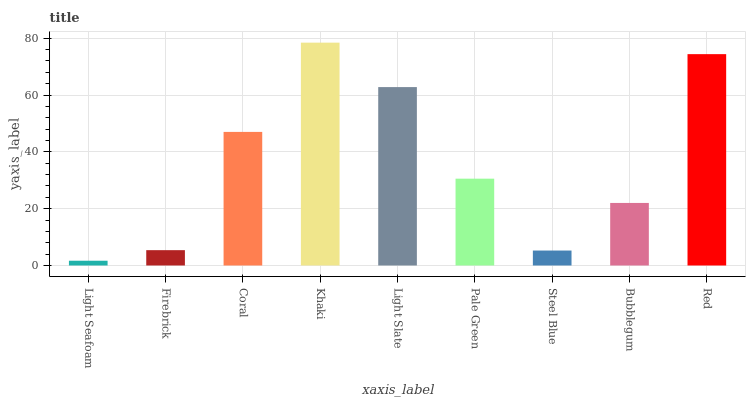Is Light Seafoam the minimum?
Answer yes or no. Yes. Is Khaki the maximum?
Answer yes or no. Yes. Is Firebrick the minimum?
Answer yes or no. No. Is Firebrick the maximum?
Answer yes or no. No. Is Firebrick greater than Light Seafoam?
Answer yes or no. Yes. Is Light Seafoam less than Firebrick?
Answer yes or no. Yes. Is Light Seafoam greater than Firebrick?
Answer yes or no. No. Is Firebrick less than Light Seafoam?
Answer yes or no. No. Is Pale Green the high median?
Answer yes or no. Yes. Is Pale Green the low median?
Answer yes or no. Yes. Is Bubblegum the high median?
Answer yes or no. No. Is Light Slate the low median?
Answer yes or no. No. 